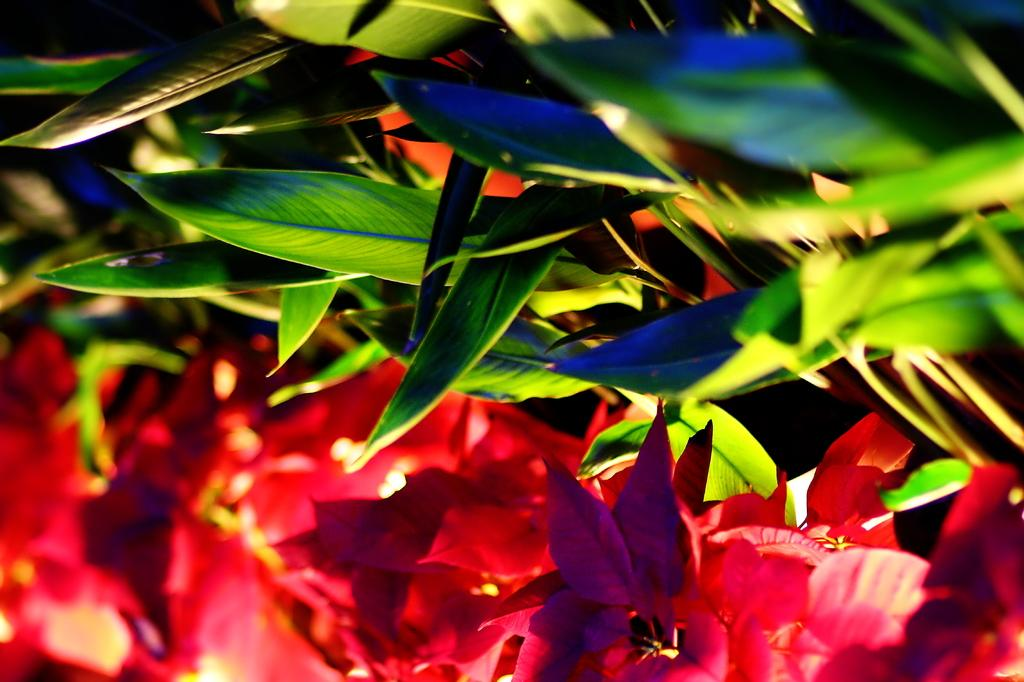What colors can be seen in the leaves at the top of the image? The leaves at the top of the image are green in color. What colors can be seen in the flowers at the bottom of the image? The flowers at the bottom of the image are red in color. Can you see a veil covering the flowers in the image? There is no veil present in the image; the flowers are visible and not covered. 